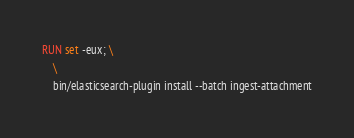Convert code to text. <code><loc_0><loc_0><loc_500><loc_500><_Dockerfile_>RUN set -eux; \
    \
    bin/elasticsearch-plugin install --batch ingest-attachment
</code> 